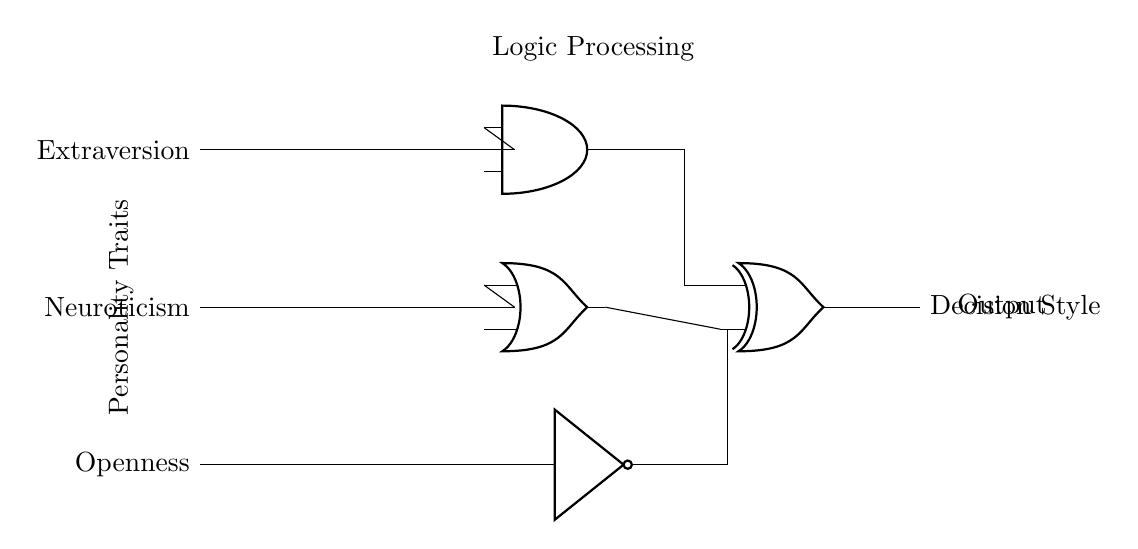What are the components for input? The input components in the circuit are three switches representing personality traits: Extraversion, Neuroticism, and Openness.
Answer: Three switches What logic gate is used for the output processing? The output processing uses an exclusive OR (XOR) gate to process the combined outputs from the preceding gates.
Answer: XOR gate How many unique personality traits are assessed in this circuit? The circuit assesses three unique personality traits, as indicated by the three input switches.
Answer: Three What type of logic gate is used for processing Neuroticism? The Neuroticism switch is connected to an OR gate, indicating this trait undergoes OR logic processing.
Answer: OR gate How many different outputs can be generated by this circuit? Since there are three inputs, the circuit can generate up to eight different combinations of outputs, based on the truth table for three variables.
Answer: Eight What type of output does this circuit produce? The final output of the circuit is labeled as "Decision Style," indicating the outcome of the personality assessment process.
Answer: Decision Style 